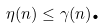Convert formula to latex. <formula><loc_0><loc_0><loc_500><loc_500>\eta ( n ) \leq \gamma ( n ) \text {.}</formula> 